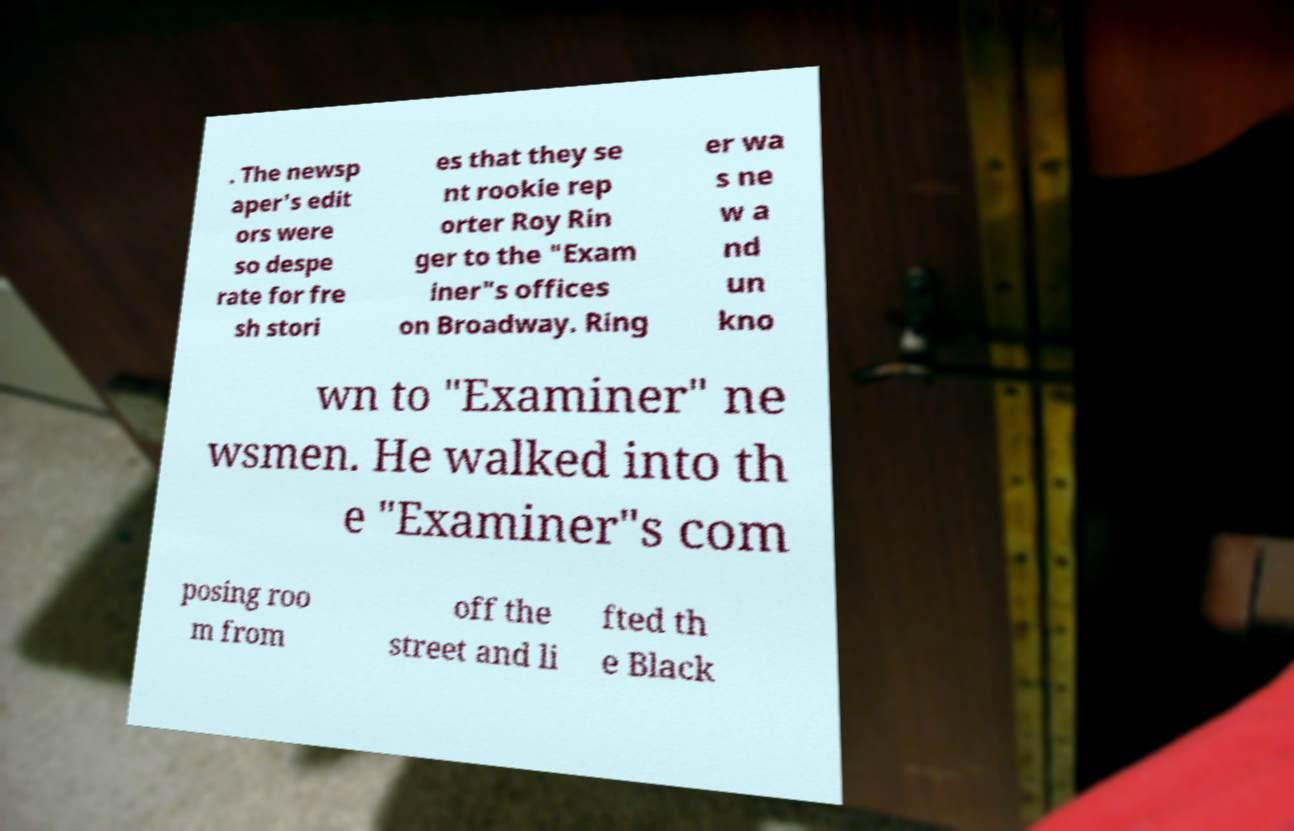For documentation purposes, I need the text within this image transcribed. Could you provide that? . The newsp aper's edit ors were so despe rate for fre sh stori es that they se nt rookie rep orter Roy Rin ger to the "Exam iner"s offices on Broadway. Ring er wa s ne w a nd un kno wn to "Examiner" ne wsmen. He walked into th e "Examiner"s com posing roo m from off the street and li fted th e Black 